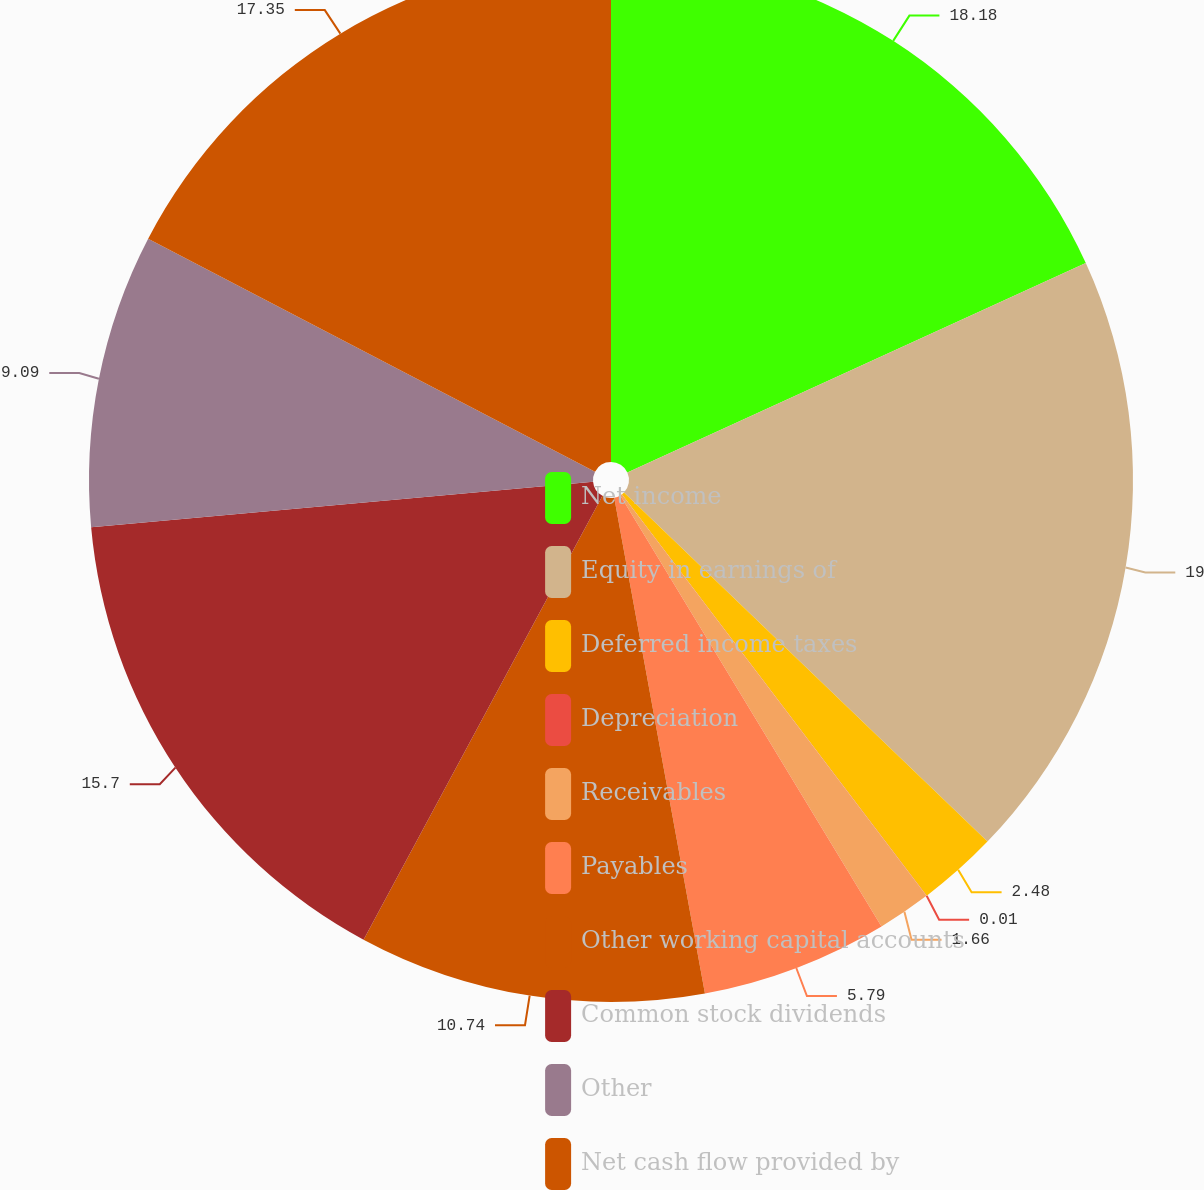Convert chart to OTSL. <chart><loc_0><loc_0><loc_500><loc_500><pie_chart><fcel>Net income<fcel>Equity in earnings of<fcel>Deferred income taxes<fcel>Depreciation<fcel>Receivables<fcel>Payables<fcel>Other working capital accounts<fcel>Common stock dividends<fcel>Other<fcel>Net cash flow provided by<nl><fcel>18.18%<fcel>19.0%<fcel>2.48%<fcel>0.01%<fcel>1.66%<fcel>5.79%<fcel>10.74%<fcel>15.7%<fcel>9.09%<fcel>17.35%<nl></chart> 